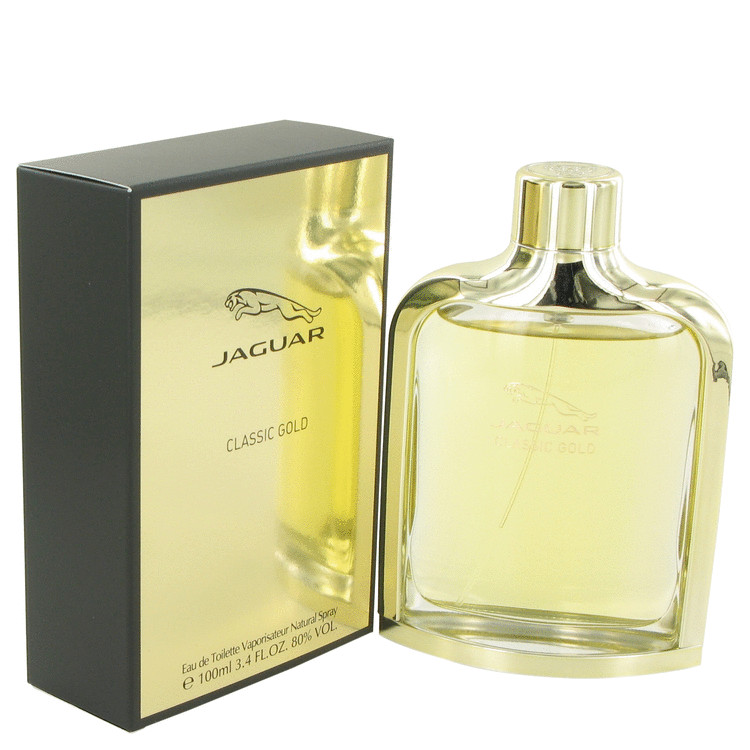What does the packaging material tell us about the quality and positioning of this perfume in the market? The packaging material offers several indications about the quality and market positioning of the perfume. The prominent use of gold coloring on the box signifies a premium or luxurious product, as gold is frequently associated with high quality and exclusivity. This suggests that the perfume is marketed as a high-end item. Furthermore, the matte black backing establishes a contrasting sophisticated appeal, which further reinforces the product's luxurious image. The reflective surface of the gold portion of the box implies that the brand aims to attract attention, targeting consumers who prefer visually striking and elegant products, indicating a focus on status and elegance. Additionally, the elegant, minimalist design of both the bottle and packaging suggests that the brand is positioning the perfume as a classic and timeless choice, likely appealing to a mature and discerning audience. 